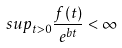Convert formula to latex. <formula><loc_0><loc_0><loc_500><loc_500>s u p _ { t > 0 } \frac { f ( t ) } { e ^ { b t } } < \infty</formula> 